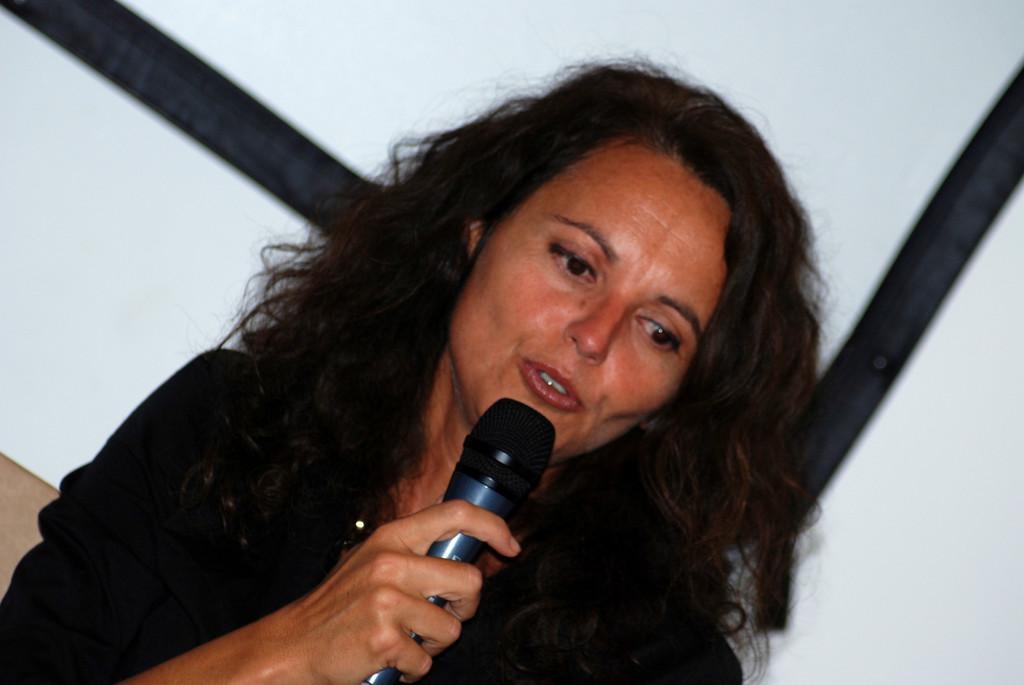Describe this image in one or two sentences. In the image we can see a woman who is holding mic in her hand and she is wearing black colour dress at the back. The background is in white colour. 